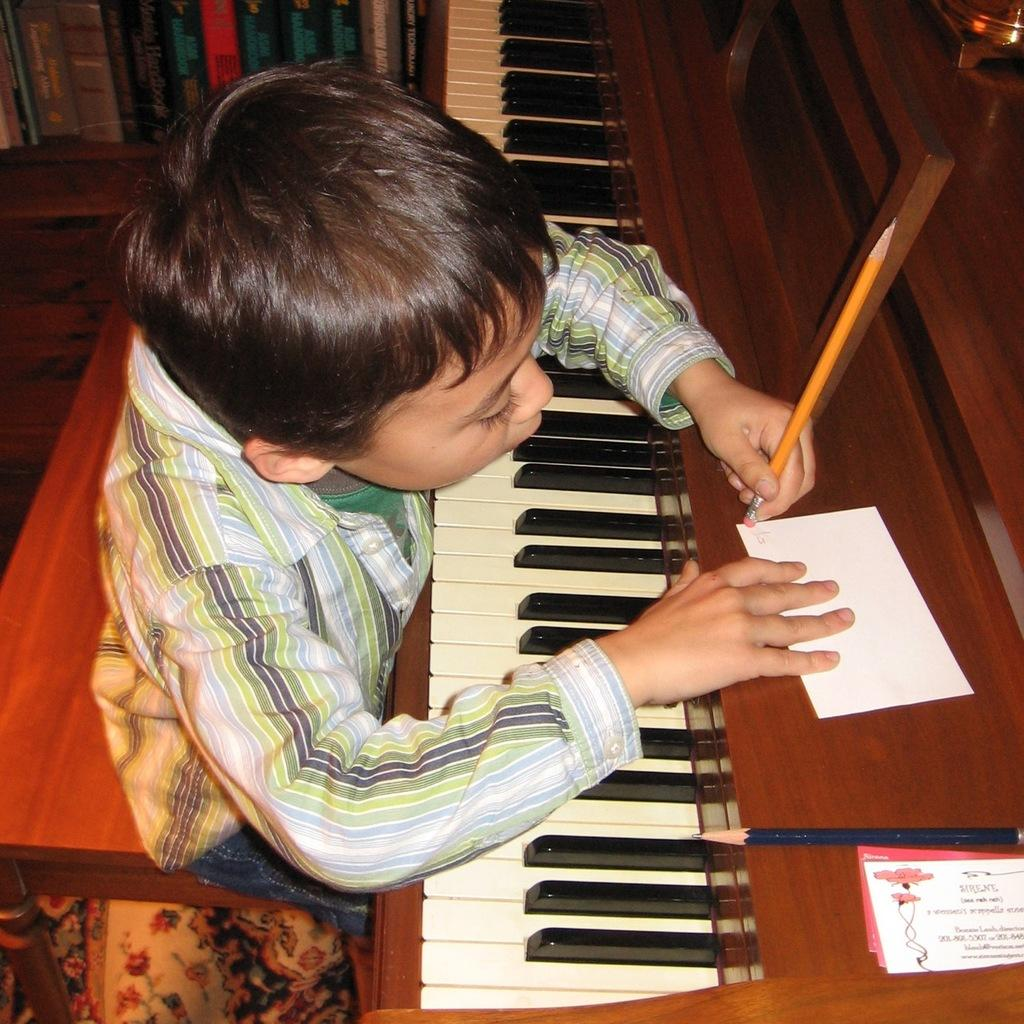Who is present in the image? There is a boy in the image. What is the boy holding in the image? The boy is holding a pencil. What other object can be seen in the image? There is a musical instrument in the image. What type of property is visible in the background of the image? There is no property visible in the background of the image. Is there a sheet of paper on the floor in the image? There is no sheet of paper mentioned or visible in the image. 